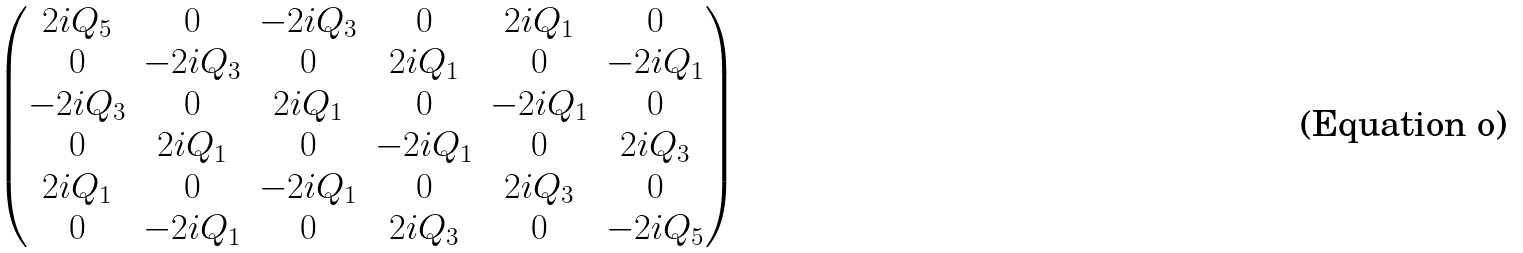<formula> <loc_0><loc_0><loc_500><loc_500>\begin{pmatrix} 2 i Q _ { 5 } & 0 & - 2 i Q _ { 3 } & 0 & 2 i Q _ { 1 } & 0 \\ 0 & - 2 i Q _ { 3 } & 0 & 2 i Q _ { 1 } & 0 & - 2 i Q _ { 1 } \\ - 2 i Q _ { 3 } & 0 & 2 i Q _ { 1 } & 0 & - 2 i Q _ { 1 } & 0 \\ 0 & 2 i Q _ { 1 } & 0 & - 2 i Q _ { 1 } & 0 & 2 i Q _ { 3 } \\ 2 i Q _ { 1 } & 0 & - 2 i Q _ { 1 } & 0 & 2 i Q _ { 3 } & 0 \\ 0 & - 2 i Q _ { 1 } & 0 & 2 i Q _ { 3 } & 0 & - 2 i Q _ { 5 } \\ \end{pmatrix}</formula> 